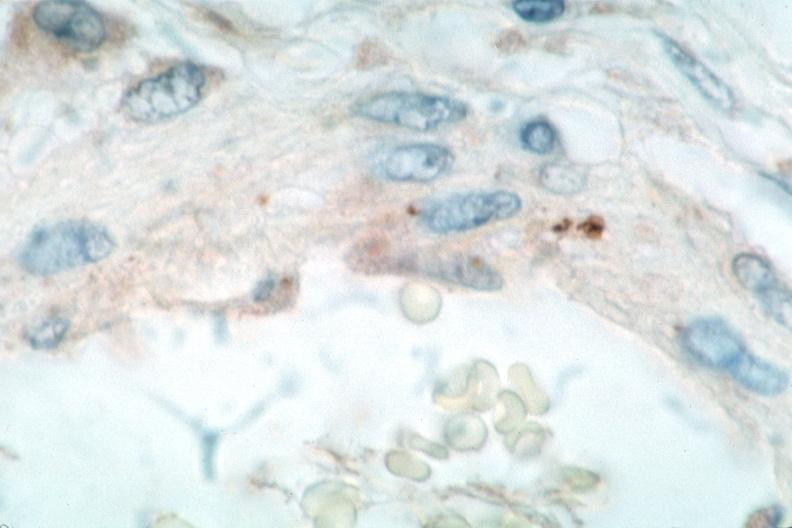does this image show vasculitis?
Answer the question using a single word or phrase. Yes 